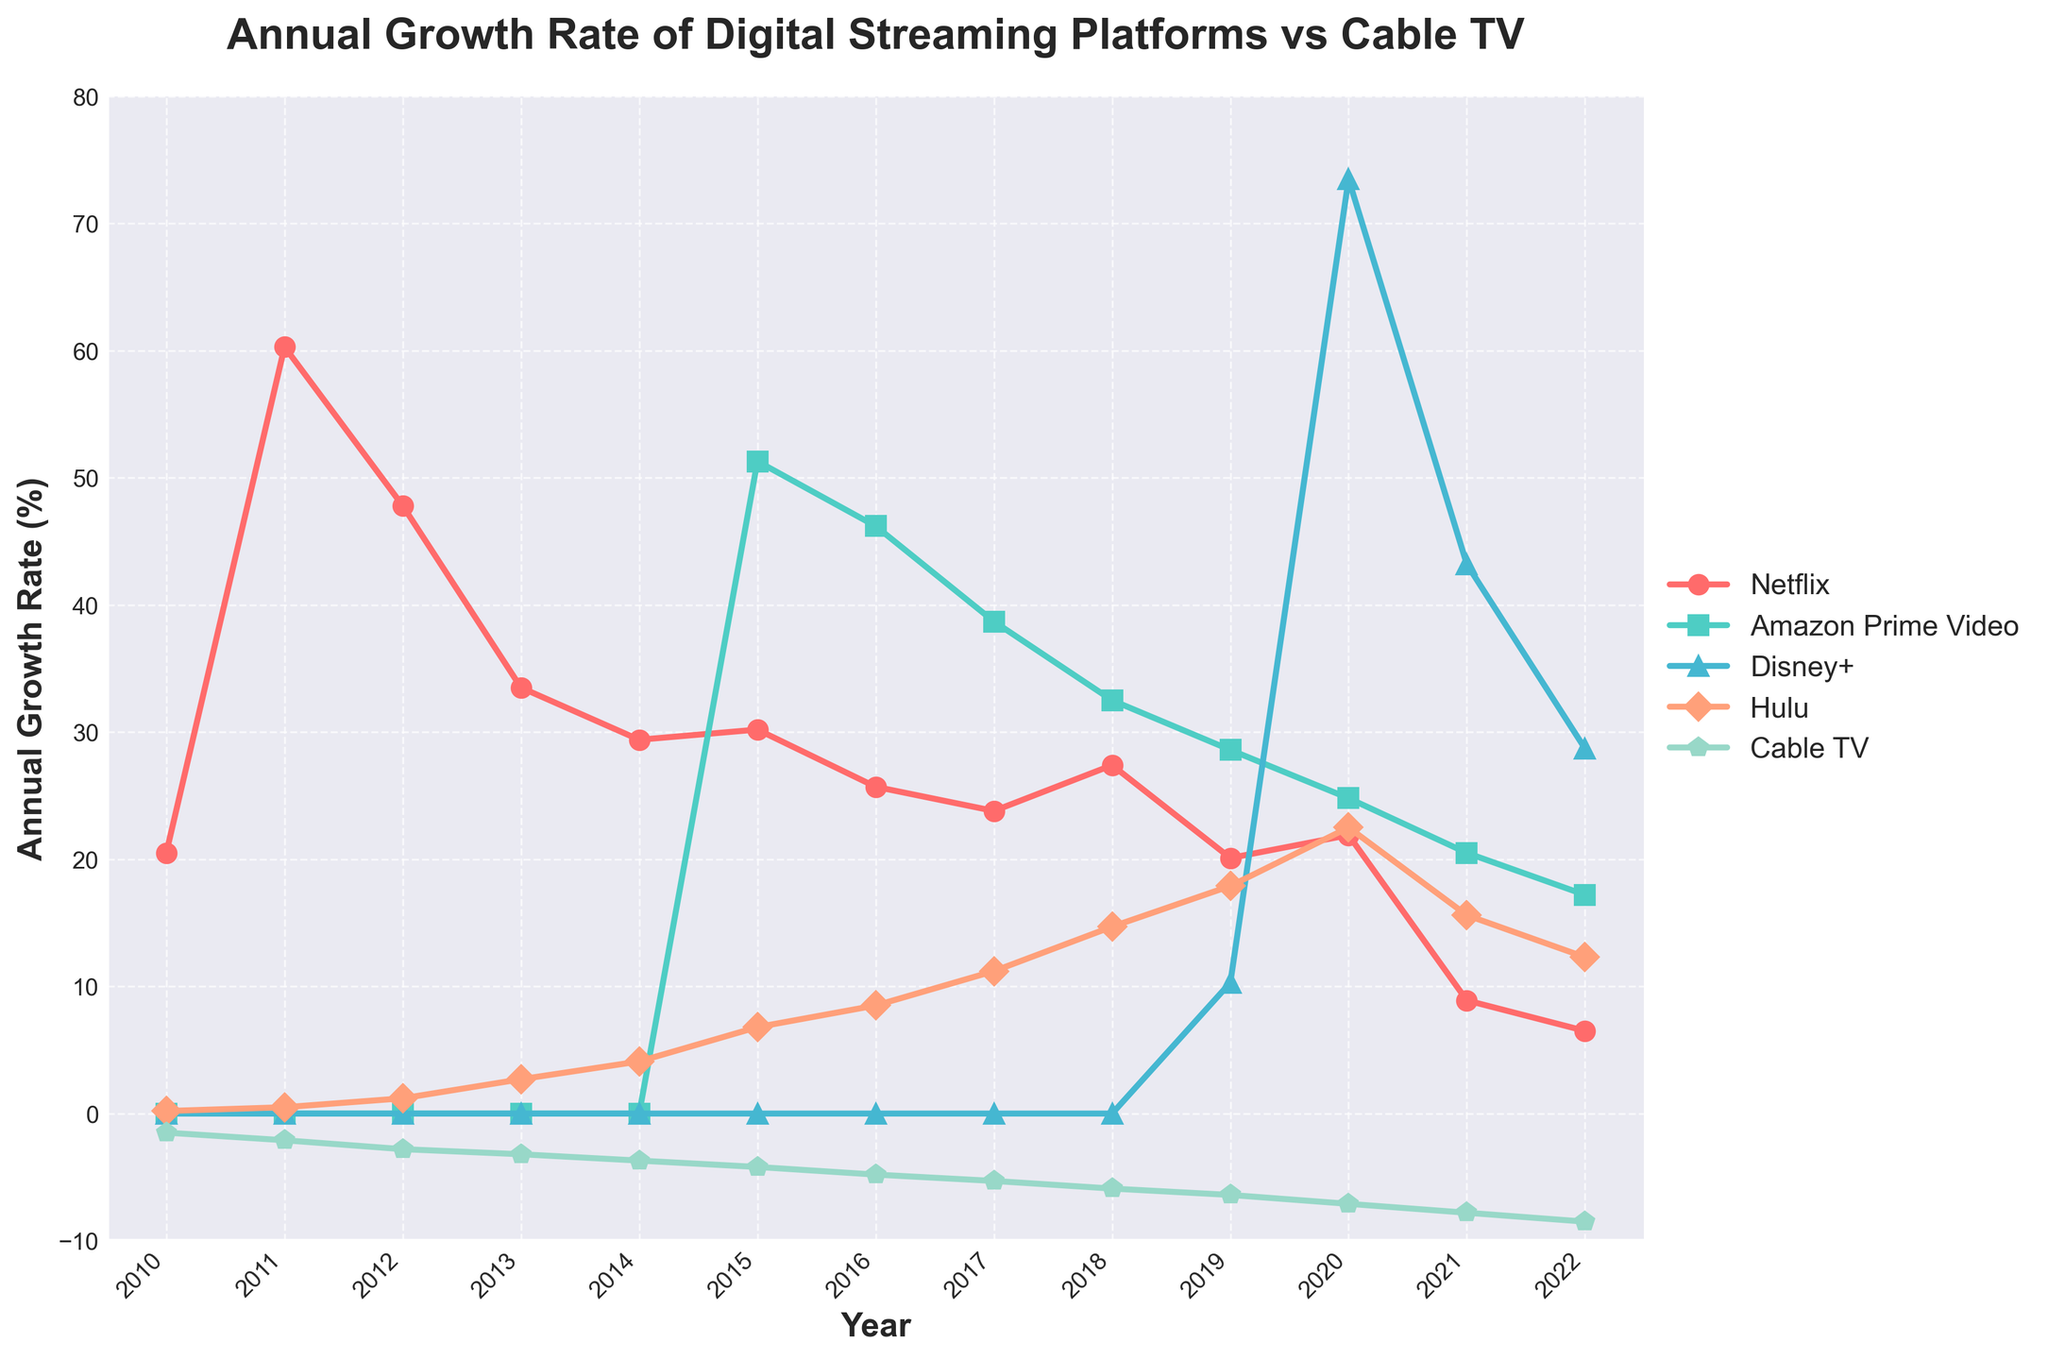What's the average annual growth rate of Netflix from 2010 to 2022? First, sum all the Netflix growth rates from 2010 to 2022: 20.5 + 60.3 + 47.8 + 33.5 + 29.4 + 30.2 + 25.7 + 23.8 + 27.4 + 20.1 + 21.9 + 8.9 + 6.5 = 356. Remove the zeros as they are not included. There are 13 years of data, so divide the sum by 13: 356 / 13 = 27.38.
Answer: 27.38% Which year did Disney+ see its highest annual growth rate? Looking at the Disney+ growth rate data, we observe that in 2020 the growth rate is significantly higher than in other years, at 73.5.
Answer: 2020 Compare the growth rate of Hulu and Cable TV in 2019. Which one saw a higher change and by how much? Hulu's growth rate in 2019 is 17.9, and Cable TV's growth rate is -6.4. The difference is 17.9 - (-6.4) = 17.9 + 6.4 = 24.3, meaning Hulu saw a higher change by 24.3 percentage points.
Answer: Hulu by 24.3 Which platform had no subscribers before 2019? Look at the data for each platform. Disney+ has growth rates of 0 from 2010 to 2018 and starts having subscribers in 2019.
Answer: Disney+ Did any platforms experience a decline in growth rate over the years? Examine the trends. Cable TV growth rates declined every year from 2010 (-1.5) to 2022 (-8.5).
Answer: Cable TV In 2015, how much larger was Amazon Prime Video's growth rate compared to Hulu's growth rate? Amazon Prime Video had a growth rate of 51.3, and Hulu had a growth rate of 6.8 in 2015. The difference is 51.3 - 6.8 = 44.5.
Answer: 44.5 What is the trend in the annual growth rates of Cable TV from 2010 to 2022? The Cable TV growth rate starts at -1.5 in 2010 and steadily declines to -8.5 in 2022, indicating a continuous decrease over the years.
Answer: Continuous decrease How many platforms showed positive growth rates every year since their inception? Inspecting the data, Netflix, Hulu, Amazon Prime Video, and Disney+ show positive growth rates each year since their inception.
Answer: 4 